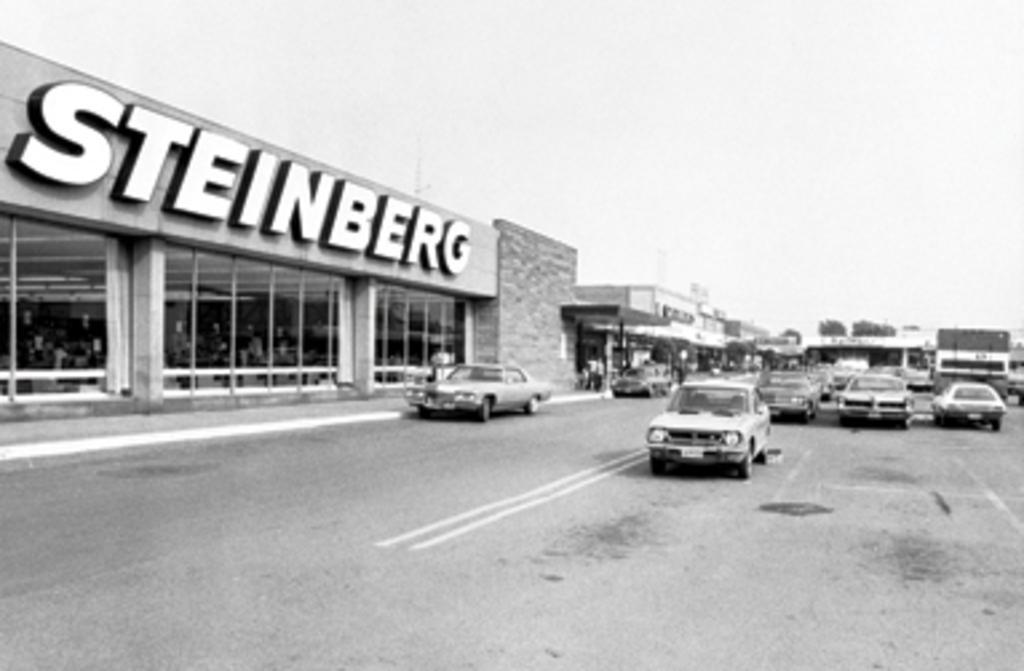Can you describe this image briefly? In this image I can see buildings on the right hand side. I can see a road on the left hand side with some vehicles. I can see a board on the building with some text. At the top of the image I can see the sky.  